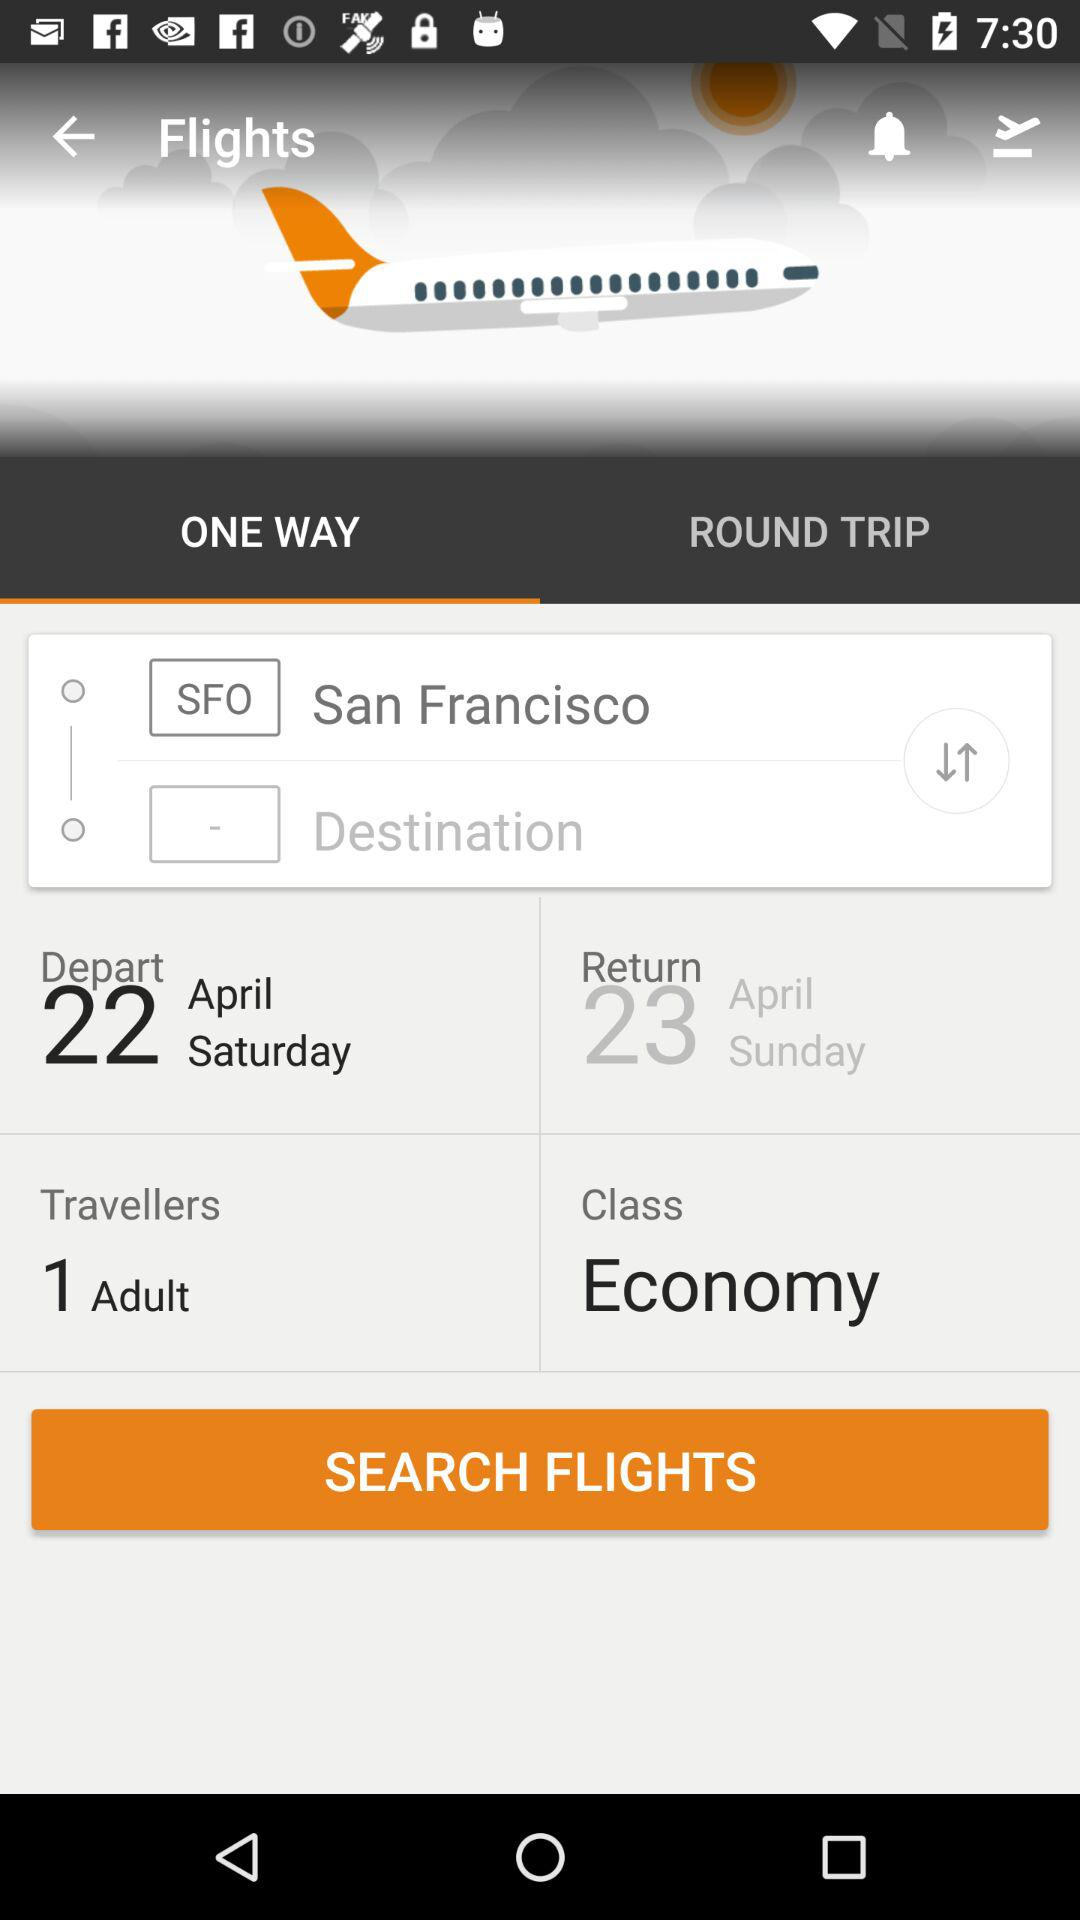How many days are there between the departure and return dates?
Answer the question using a single word or phrase. 1 